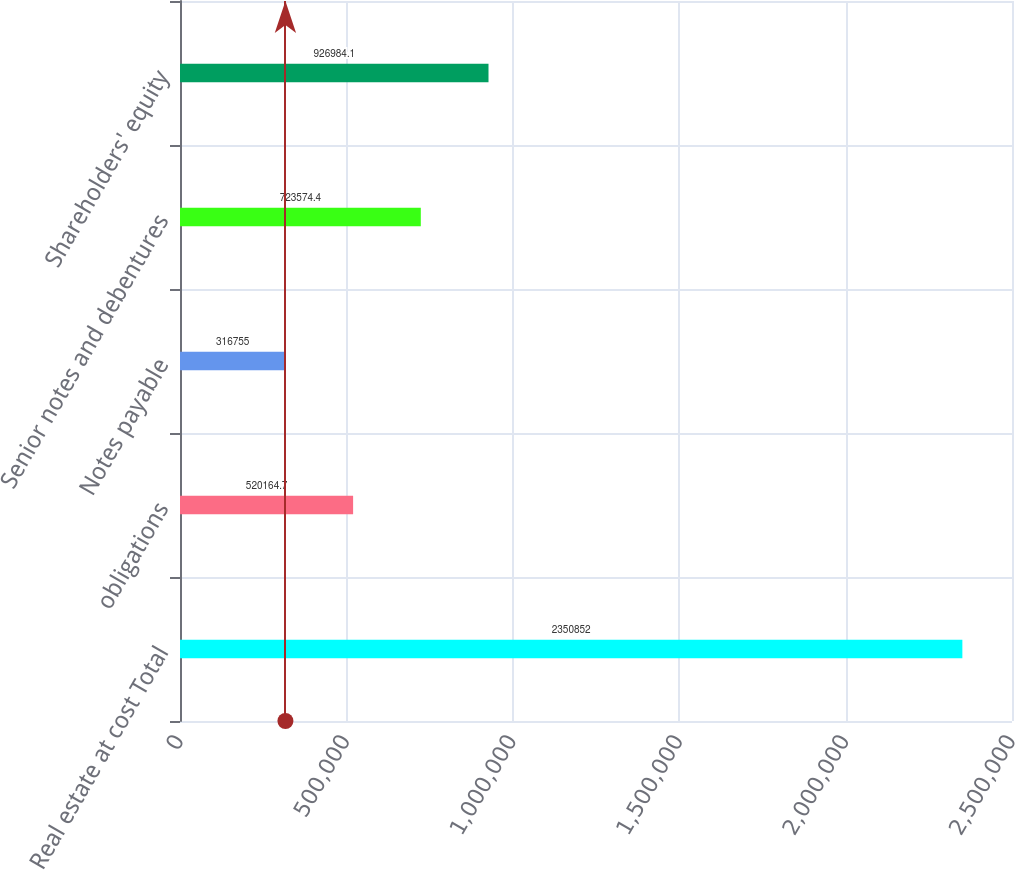Convert chart. <chart><loc_0><loc_0><loc_500><loc_500><bar_chart><fcel>Real estate at cost Total<fcel>obligations<fcel>Notes payable<fcel>Senior notes and debentures<fcel>Shareholders' equity<nl><fcel>2.35085e+06<fcel>520165<fcel>316755<fcel>723574<fcel>926984<nl></chart> 